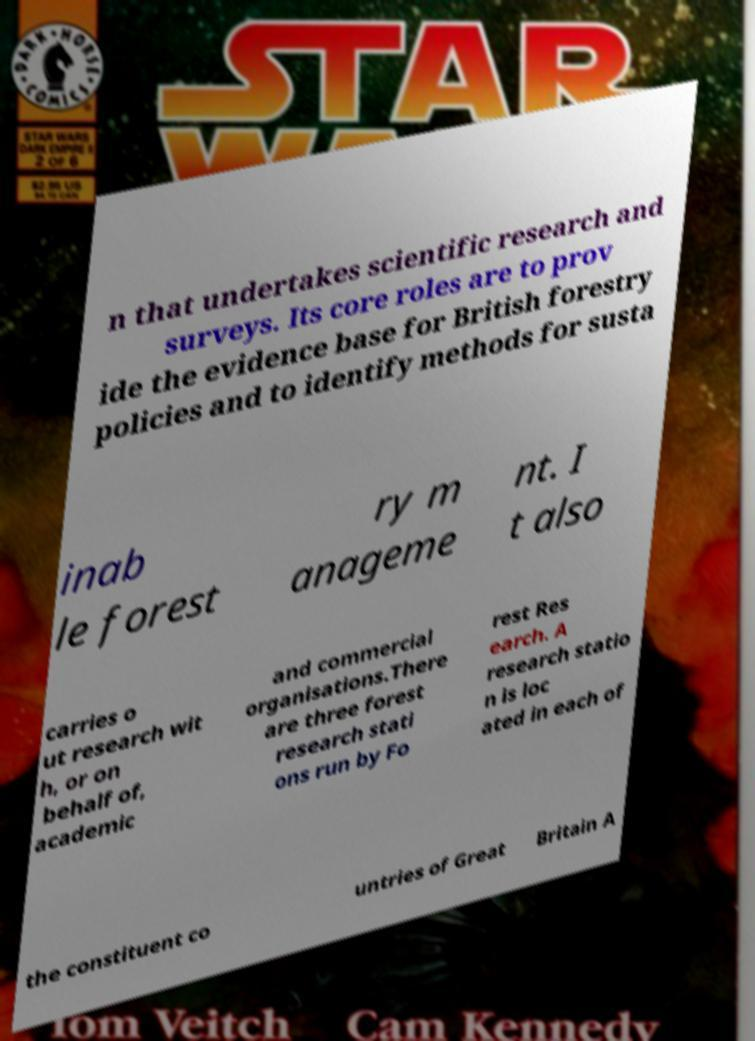There's text embedded in this image that I need extracted. Can you transcribe it verbatim? n that undertakes scientific research and surveys. Its core roles are to prov ide the evidence base for British forestry policies and to identify methods for susta inab le forest ry m anageme nt. I t also carries o ut research wit h, or on behalf of, academic and commercial organisations.There are three forest research stati ons run by Fo rest Res earch. A research statio n is loc ated in each of the constituent co untries of Great Britain A 